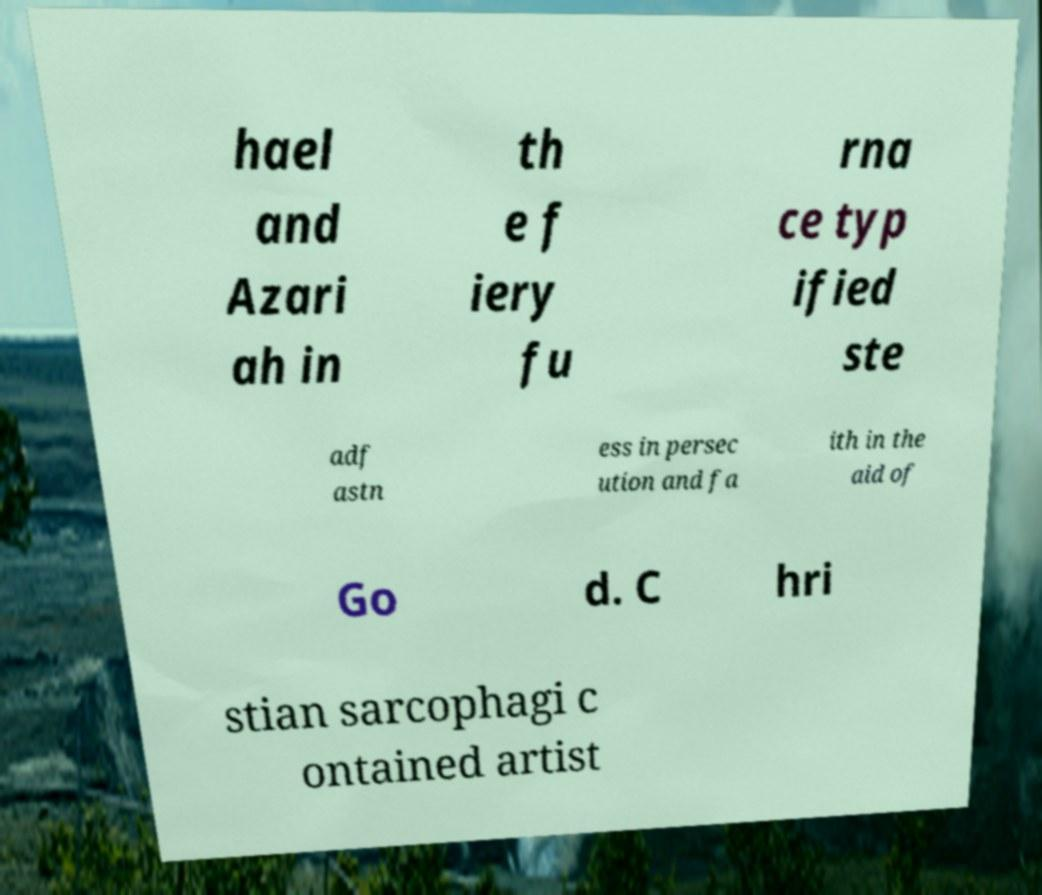Can you read and provide the text displayed in the image?This photo seems to have some interesting text. Can you extract and type it out for me? hael and Azari ah in th e f iery fu rna ce typ ified ste adf astn ess in persec ution and fa ith in the aid of Go d. C hri stian sarcophagi c ontained artist 